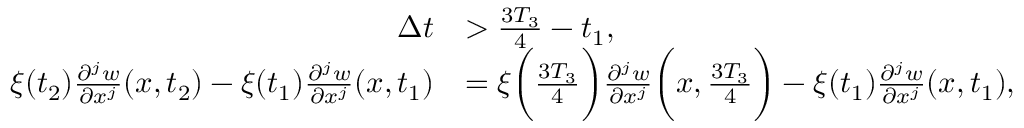Convert formula to latex. <formula><loc_0><loc_0><loc_500><loc_500>\begin{array} { r l } { \Delta t } & { > \frac { 3 T _ { 3 } } { 4 } - t _ { 1 } , } \\ { \xi ( t _ { 2 } ) \frac { \partial ^ { j } w } { \partial x ^ { j } } ( x , t _ { 2 } ) - \xi ( t _ { 1 } ) \frac { \partial ^ { j } w } { \partial x ^ { j } } ( x , t _ { 1 } ) } & { = \xi \left ( \frac { 3 T _ { 3 } } { 4 } \right ) \frac { \partial ^ { j } w } { \partial x ^ { j } } \left ( x , \frac { 3 T _ { 3 } } { 4 } \right ) - \xi ( t _ { 1 } ) \frac { \partial ^ { j } w } { \partial x ^ { j } } ( x , t _ { 1 } ) , } \end{array}</formula> 